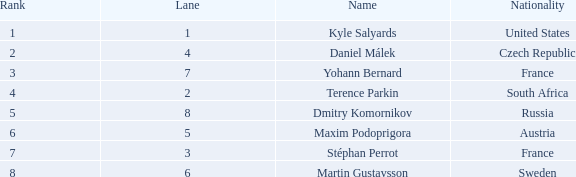What was Maxim Podoprigora's lowest rank? 6.0. 